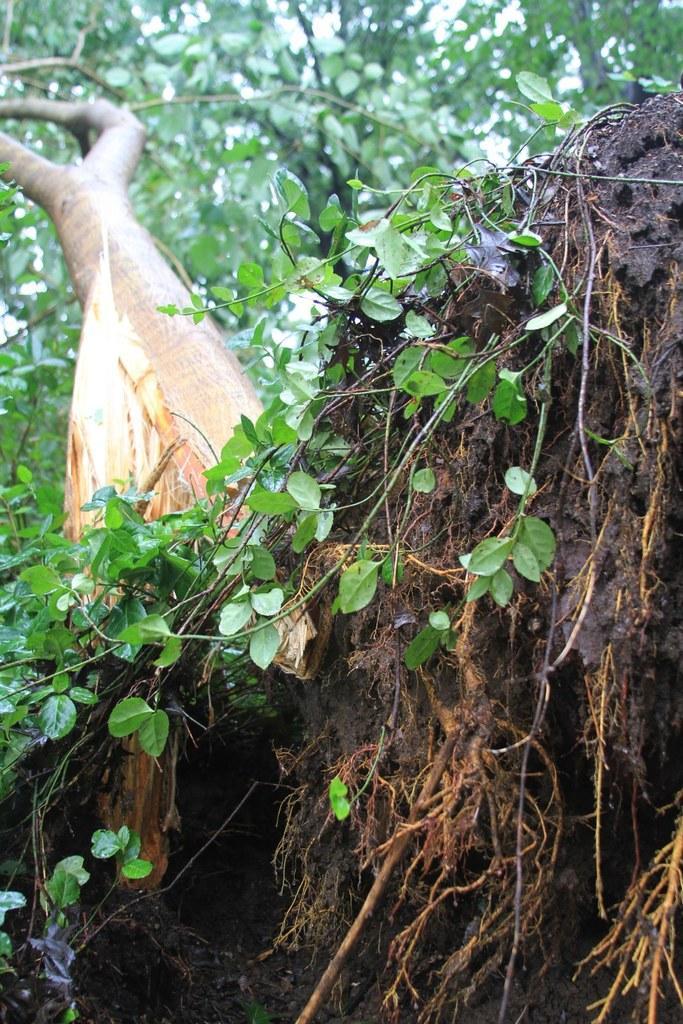How would you summarize this image in a sentence or two? In this picture I can see there is a tree, it has a trunk and I can see the roots, soil and some leaves. 